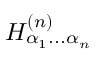<formula> <loc_0><loc_0><loc_500><loc_500>H _ { \alpha _ { 1 } \dots \alpha _ { n } } ^ { ( n ) }</formula> 